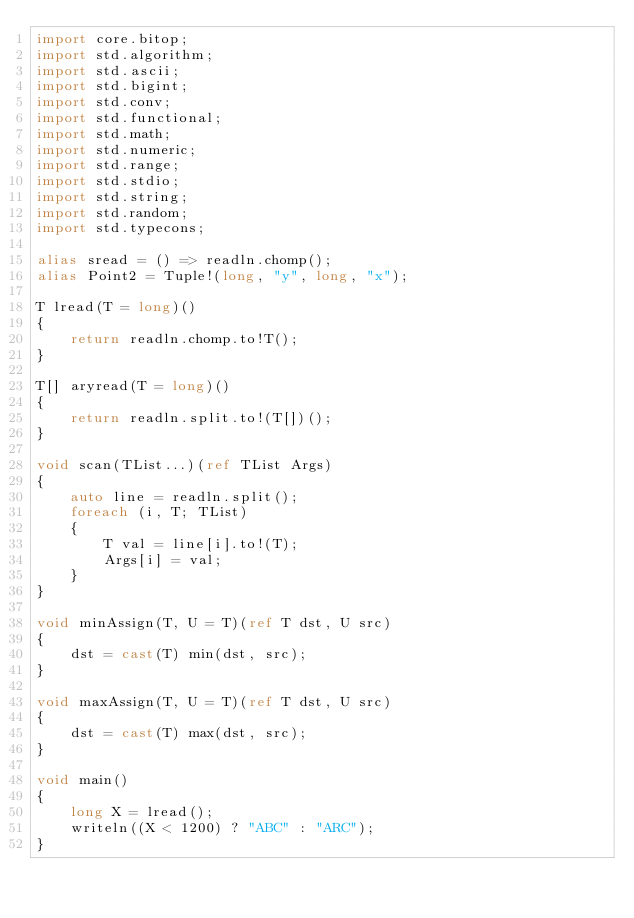<code> <loc_0><loc_0><loc_500><loc_500><_D_>import core.bitop;
import std.algorithm;
import std.ascii;
import std.bigint;
import std.conv;
import std.functional;
import std.math;
import std.numeric;
import std.range;
import std.stdio;
import std.string;
import std.random;
import std.typecons;

alias sread = () => readln.chomp();
alias Point2 = Tuple!(long, "y", long, "x");

T lread(T = long)()
{
    return readln.chomp.to!T();
}

T[] aryread(T = long)()
{
    return readln.split.to!(T[])();
}

void scan(TList...)(ref TList Args)
{
    auto line = readln.split();
    foreach (i, T; TList)
    {
        T val = line[i].to!(T);
        Args[i] = val;
    }
}

void minAssign(T, U = T)(ref T dst, U src)
{
    dst = cast(T) min(dst, src);
}

void maxAssign(T, U = T)(ref T dst, U src)
{
    dst = cast(T) max(dst, src);
}

void main()
{
    long X = lread();
    writeln((X < 1200) ? "ABC" : "ARC");
}
</code> 